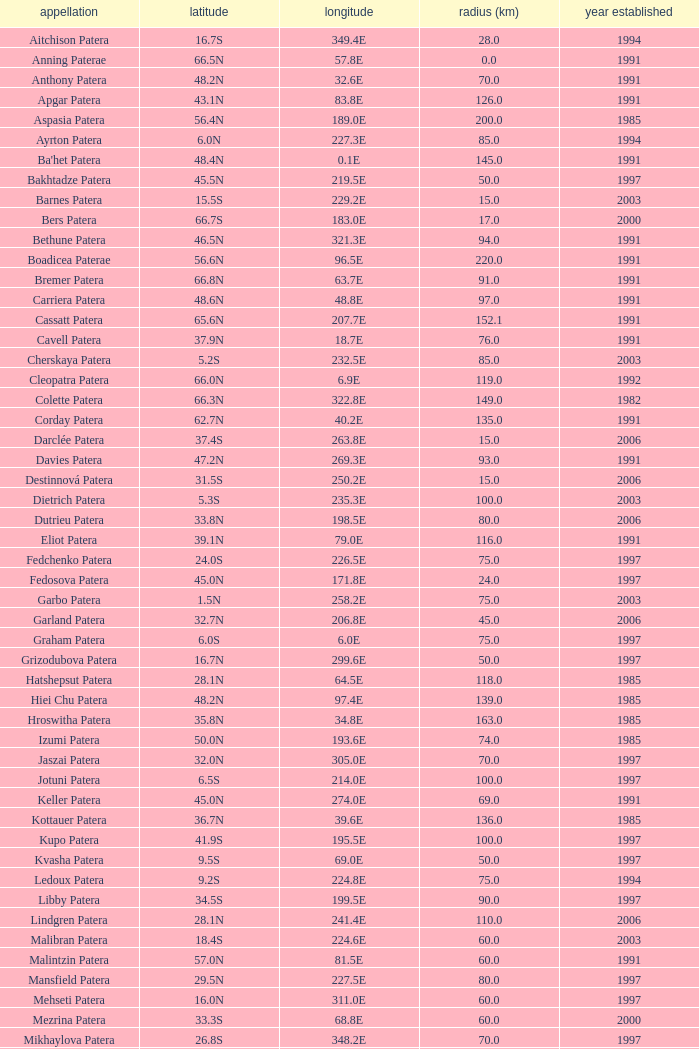What is the average Year Named, when Latitude is 37.9N, and when Diameter (km) is greater than 76? None. 